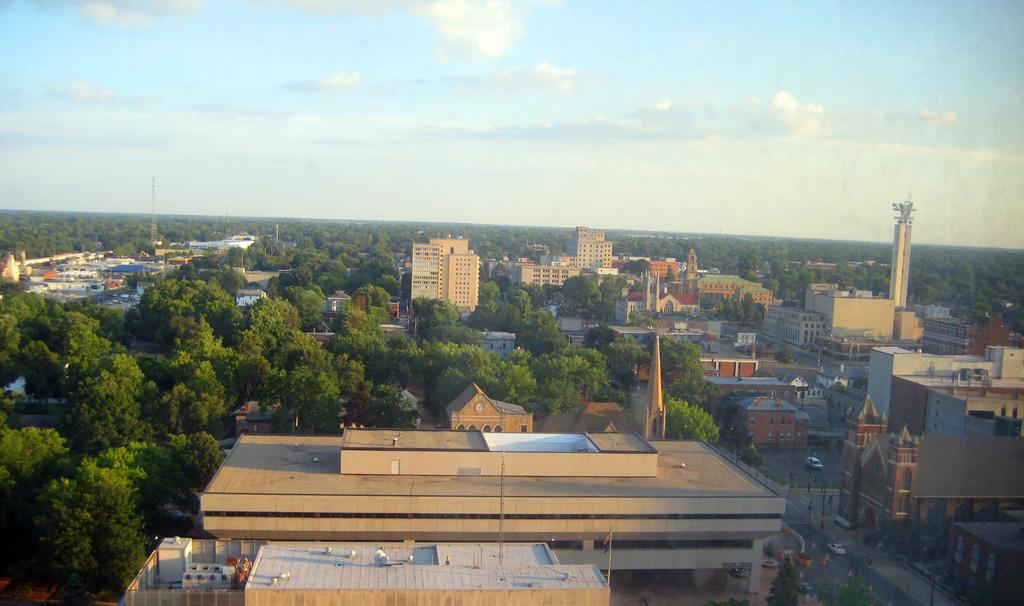What perspective is the image taken from? The image is taken from a top view. What type of natural elements can be seen in the image? There are many trees in the image. What type of man-made structures are visible in the image? There are buildings in the image. What can be seen on the right side of the image? There is a road on the right side of the image. What is present on the road? There are vehicles on the road. Where is the queen sitting in the image? There is no queen present in the image; it features a top view of an area with trees, buildings, a road, and vehicles. 